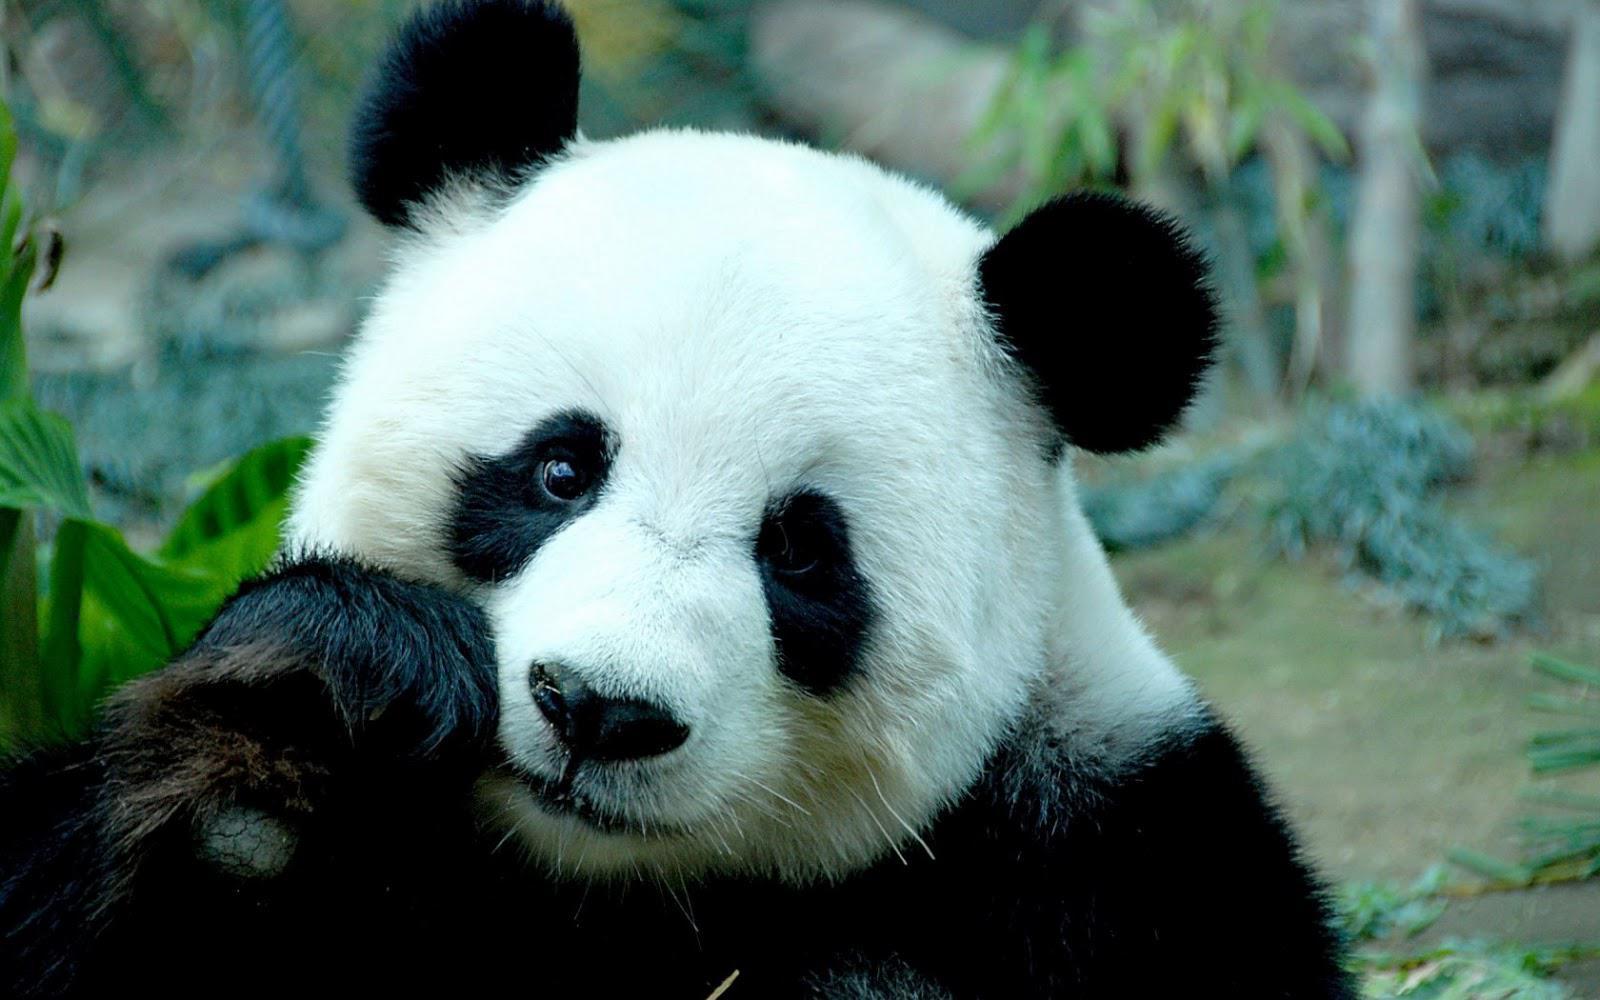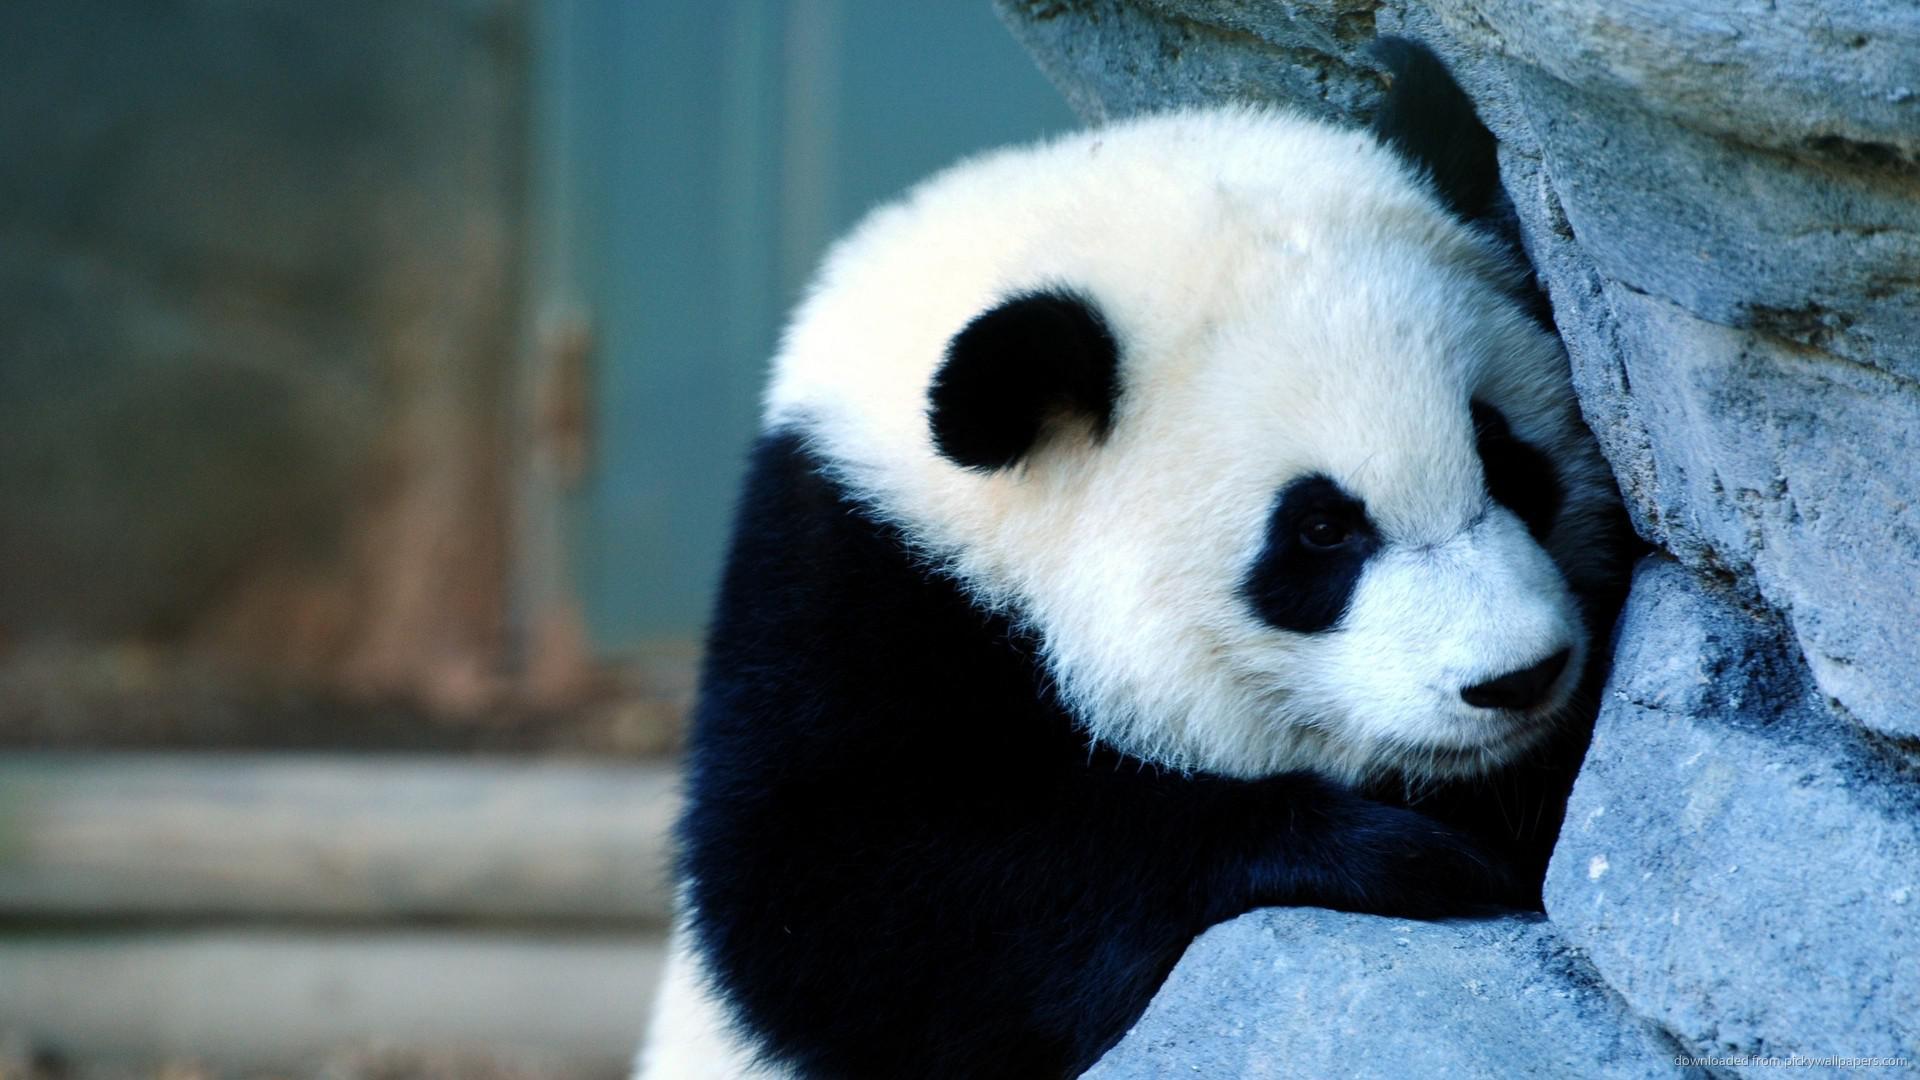The first image is the image on the left, the second image is the image on the right. Assess this claim about the two images: "The left and right image contains the same number of pandas.". Correct or not? Answer yes or no. Yes. 